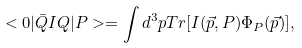<formula> <loc_0><loc_0><loc_500><loc_500>< 0 | \bar { Q } I Q | P > = \int d ^ { 3 } p T r [ I ( \vec { p } , P ) \Phi _ { P } ( \vec { p } ) ] ,</formula> 